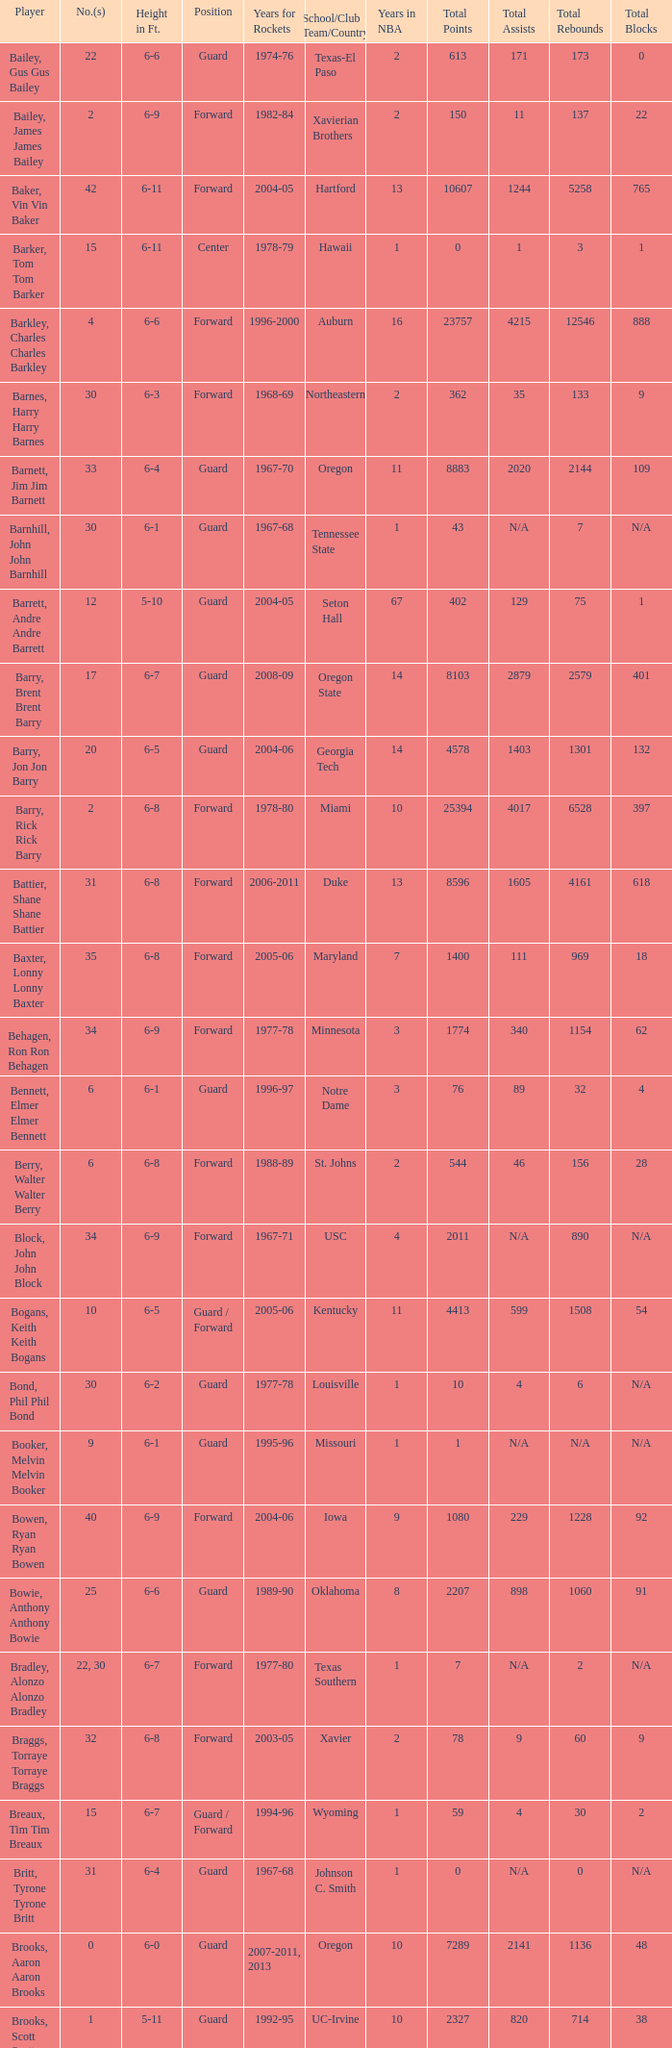What years did the player from LaSalle play for the Rockets? 1982-83. 